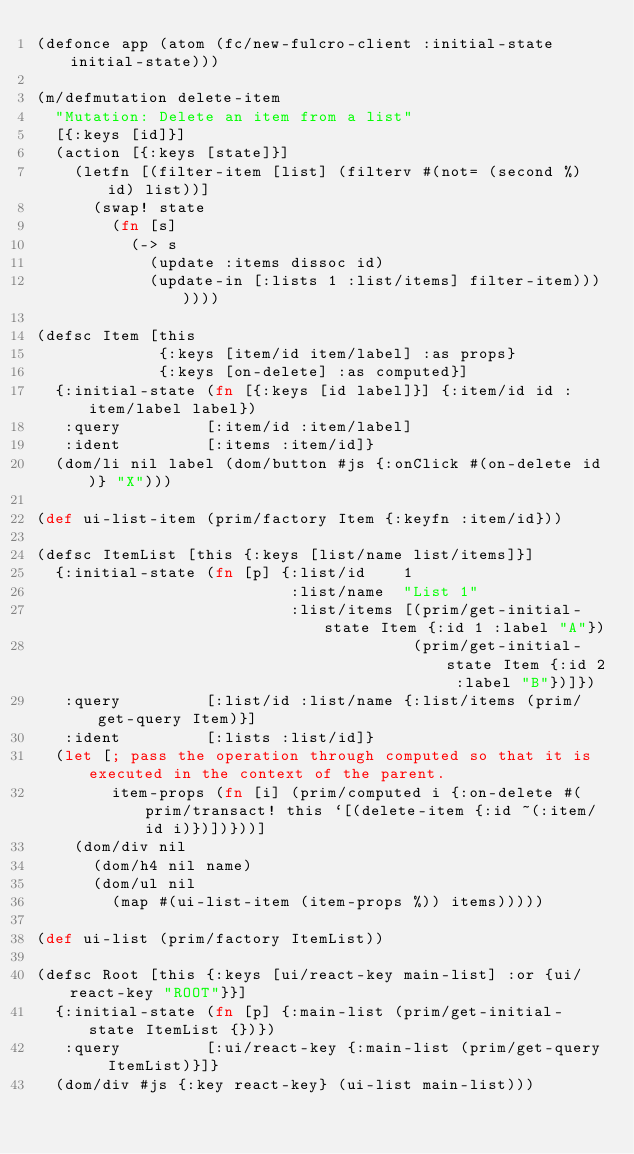<code> <loc_0><loc_0><loc_500><loc_500><_Clojure_>(defonce app (atom (fc/new-fulcro-client :initial-state initial-state)))

(m/defmutation delete-item
  "Mutation: Delete an item from a list"
  [{:keys [id]}]
  (action [{:keys [state]}]
    (letfn [(filter-item [list] (filterv #(not= (second %) id) list))]
      (swap! state
        (fn [s]
          (-> s
            (update :items dissoc id)
            (update-in [:lists 1 :list/items] filter-item)))))))

(defsc Item [this
             {:keys [item/id item/label] :as props}
             {:keys [on-delete] :as computed}]
  {:initial-state (fn [{:keys [id label]}] {:item/id id :item/label label})
   :query         [:item/id :item/label]
   :ident         [:items :item/id]}
  (dom/li nil label (dom/button #js {:onClick #(on-delete id)} "X")))

(def ui-list-item (prim/factory Item {:keyfn :item/id}))

(defsc ItemList [this {:keys [list/name list/items]}]
  {:initial-state (fn [p] {:list/id    1
                           :list/name  "List 1"
                           :list/items [(prim/get-initial-state Item {:id 1 :label "A"})
                                        (prim/get-initial-state Item {:id 2 :label "B"})]})
   :query         [:list/id :list/name {:list/items (prim/get-query Item)}]
   :ident         [:lists :list/id]}
  (let [; pass the operation through computed so that it is executed in the context of the parent.
        item-props (fn [i] (prim/computed i {:on-delete #(prim/transact! this `[(delete-item {:id ~(:item/id i)})])}))]
    (dom/div nil
      (dom/h4 nil name)
      (dom/ul nil
        (map #(ui-list-item (item-props %)) items)))))

(def ui-list (prim/factory ItemList))

(defsc Root [this {:keys [ui/react-key main-list] :or {ui/react-key "ROOT"}}]
  {:initial-state (fn [p] {:main-list (prim/get-initial-state ItemList {})})
   :query         [:ui/react-key {:main-list (prim/get-query ItemList)}]}
  (dom/div #js {:key react-key} (ui-list main-list)))


</code> 